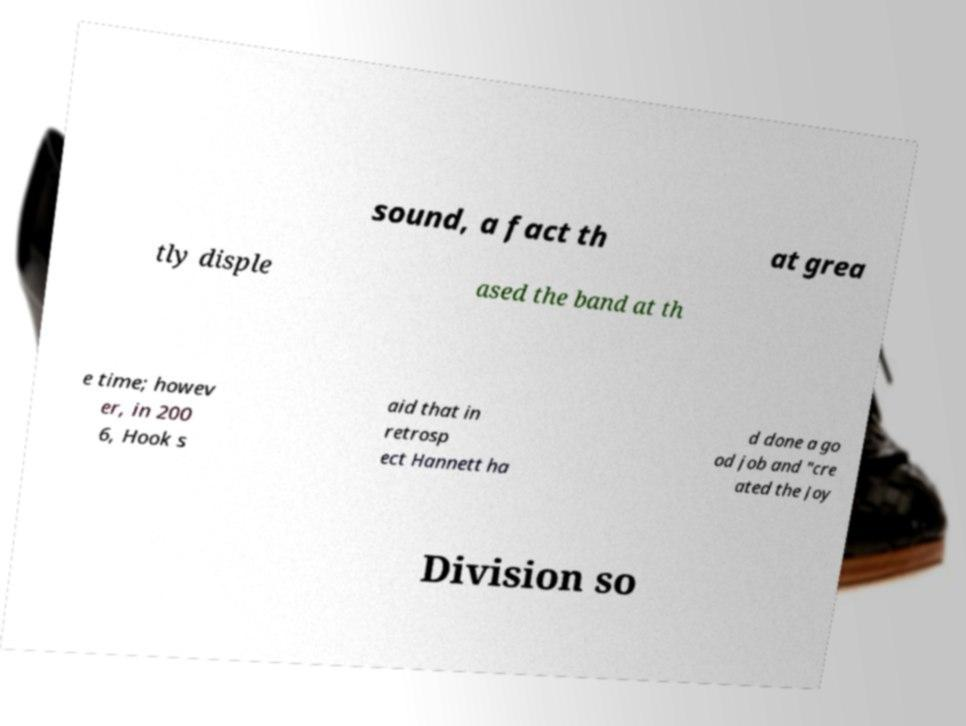Please read and relay the text visible in this image. What does it say? sound, a fact th at grea tly disple ased the band at th e time; howev er, in 200 6, Hook s aid that in retrosp ect Hannett ha d done a go od job and "cre ated the Joy Division so 